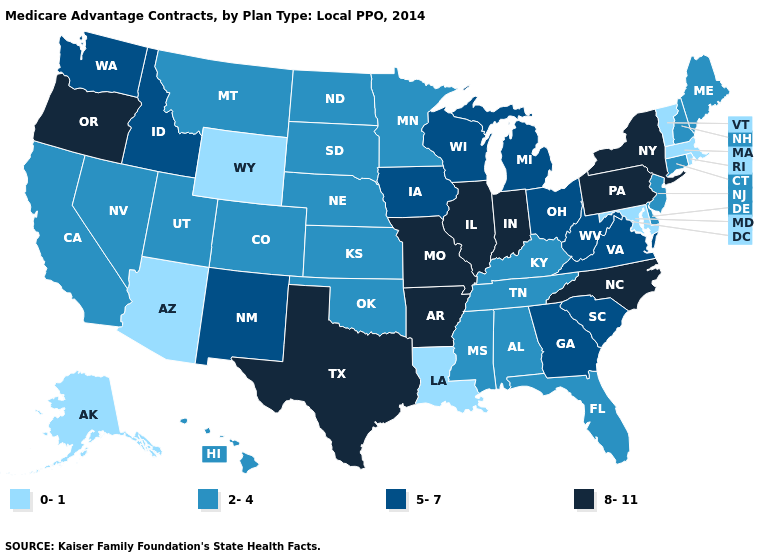How many symbols are there in the legend?
Concise answer only. 4. Does California have the highest value in the USA?
Answer briefly. No. Among the states that border Oklahoma , which have the highest value?
Answer briefly. Arkansas, Missouri, Texas. Does Georgia have the lowest value in the South?
Short answer required. No. What is the lowest value in the USA?
Be succinct. 0-1. Name the states that have a value in the range 0-1?
Quick response, please. Alaska, Arizona, Louisiana, Massachusetts, Maryland, Rhode Island, Vermont, Wyoming. What is the highest value in the West ?
Be succinct. 8-11. What is the value of Michigan?
Give a very brief answer. 5-7. What is the lowest value in the South?
Write a very short answer. 0-1. What is the value of Oklahoma?
Keep it brief. 2-4. Does Maryland have the lowest value in the South?
Write a very short answer. Yes. Name the states that have a value in the range 2-4?
Give a very brief answer. Alabama, California, Colorado, Connecticut, Delaware, Florida, Hawaii, Kansas, Kentucky, Maine, Minnesota, Mississippi, Montana, North Dakota, Nebraska, New Hampshire, New Jersey, Nevada, Oklahoma, South Dakota, Tennessee, Utah. Does the first symbol in the legend represent the smallest category?
Write a very short answer. Yes. Is the legend a continuous bar?
Concise answer only. No. Does Georgia have the highest value in the USA?
Concise answer only. No. 